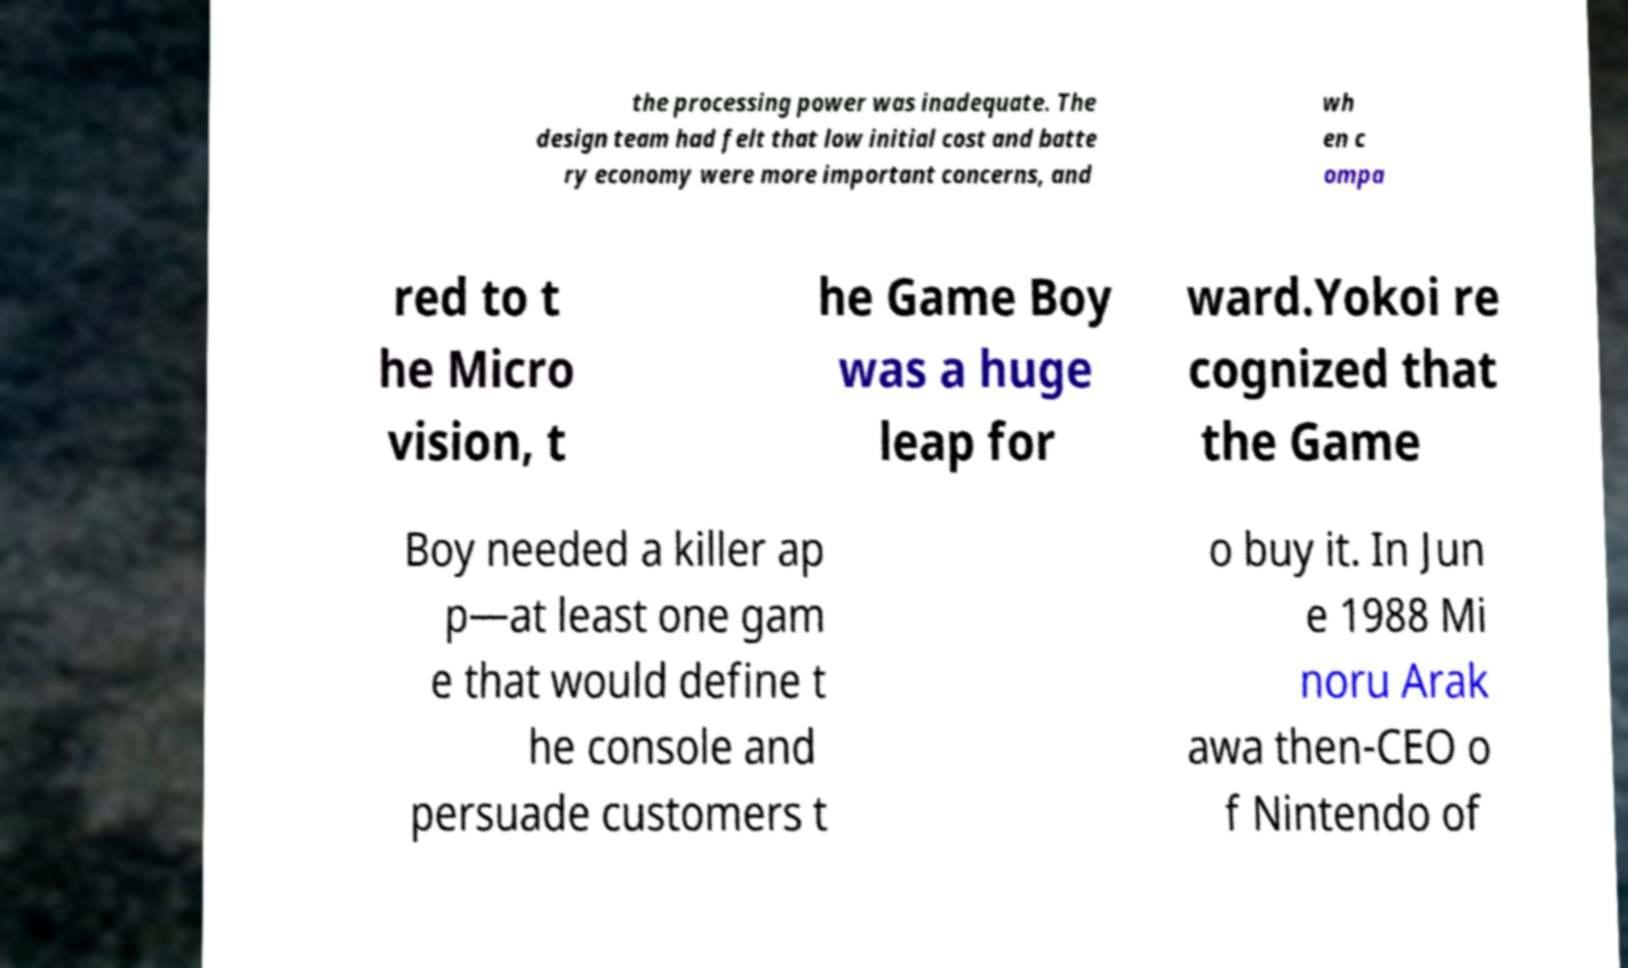Please read and relay the text visible in this image. What does it say? the processing power was inadequate. The design team had felt that low initial cost and batte ry economy were more important concerns, and wh en c ompa red to t he Micro vision, t he Game Boy was a huge leap for ward.Yokoi re cognized that the Game Boy needed a killer ap p—at least one gam e that would define t he console and persuade customers t o buy it. In Jun e 1988 Mi noru Arak awa then-CEO o f Nintendo of 